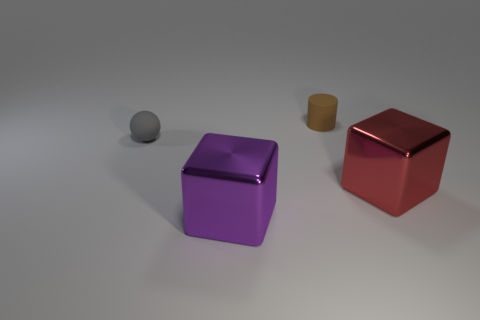How does the size of the small grey sphere compare to the other objects? The small grey sphere is noticeably smaller than the other objects. It's dwarfed by the larger cubic shapes, providing a contrast in size and form that adds to the visual interest of the scene. Could the smaller objects fit inside the larger ones? From this perspective, the smaller grey sphere and the small cylinder could potentially fit inside the larger cubes. The objects' proportional sizes suggest that the cubes have adequate volume to contain the smaller shapes. 